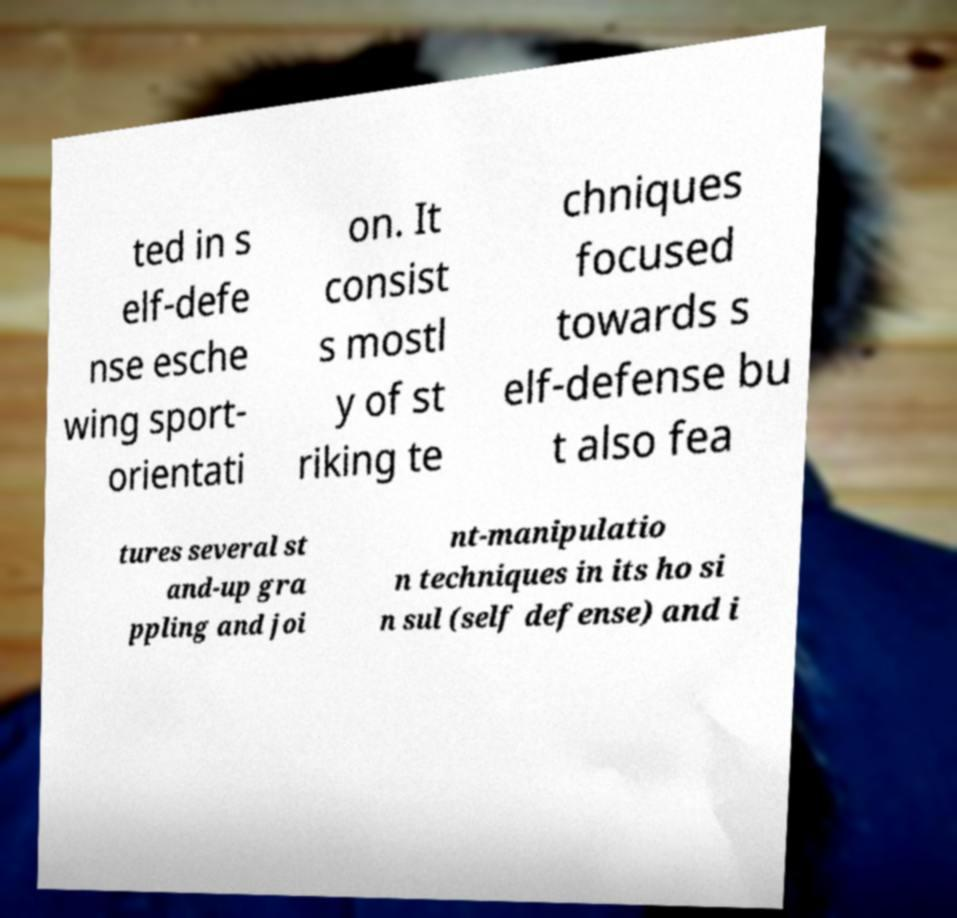What messages or text are displayed in this image? I need them in a readable, typed format. ted in s elf-defe nse esche wing sport- orientati on. It consist s mostl y of st riking te chniques focused towards s elf-defense bu t also fea tures several st and-up gra ppling and joi nt-manipulatio n techniques in its ho si n sul (self defense) and i 